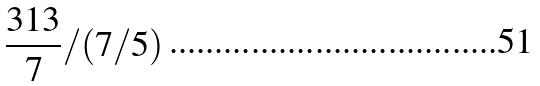<formula> <loc_0><loc_0><loc_500><loc_500>\frac { 3 1 3 } { 7 } / ( 7 / 5 )</formula> 